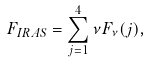<formula> <loc_0><loc_0><loc_500><loc_500>F _ { I R A S } = \sum _ { j = 1 } ^ { 4 } \nu F _ { \nu } ( j ) ,</formula> 